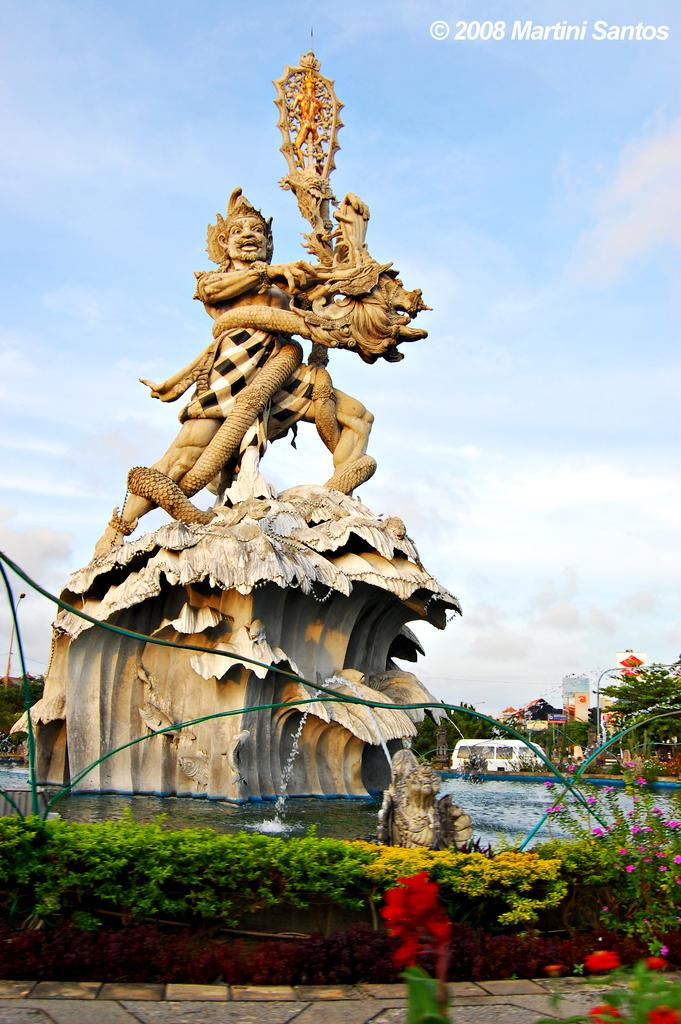What is the main subject of the image? There is a sculpture on a fountain in the image. What is surrounding the fountain? Water is present around the fountain. Are there any plants visible in the image? Yes, there are plants with flowers in the image. What can be seen in the background of the image? The sky is visible in the background of the image. What is the condition of the sky in the image? Clouds are present in the sky. What type of honey is being collected by the bees in the image? There are no bees or honey present in the image; it features a sculpture on a fountain with water, plants, and a sky with clouds. What is the temperature like in the image? The image does not provide information about the temperature, but the presence of clouds in the sky suggests it might be a partly cloudy day. 